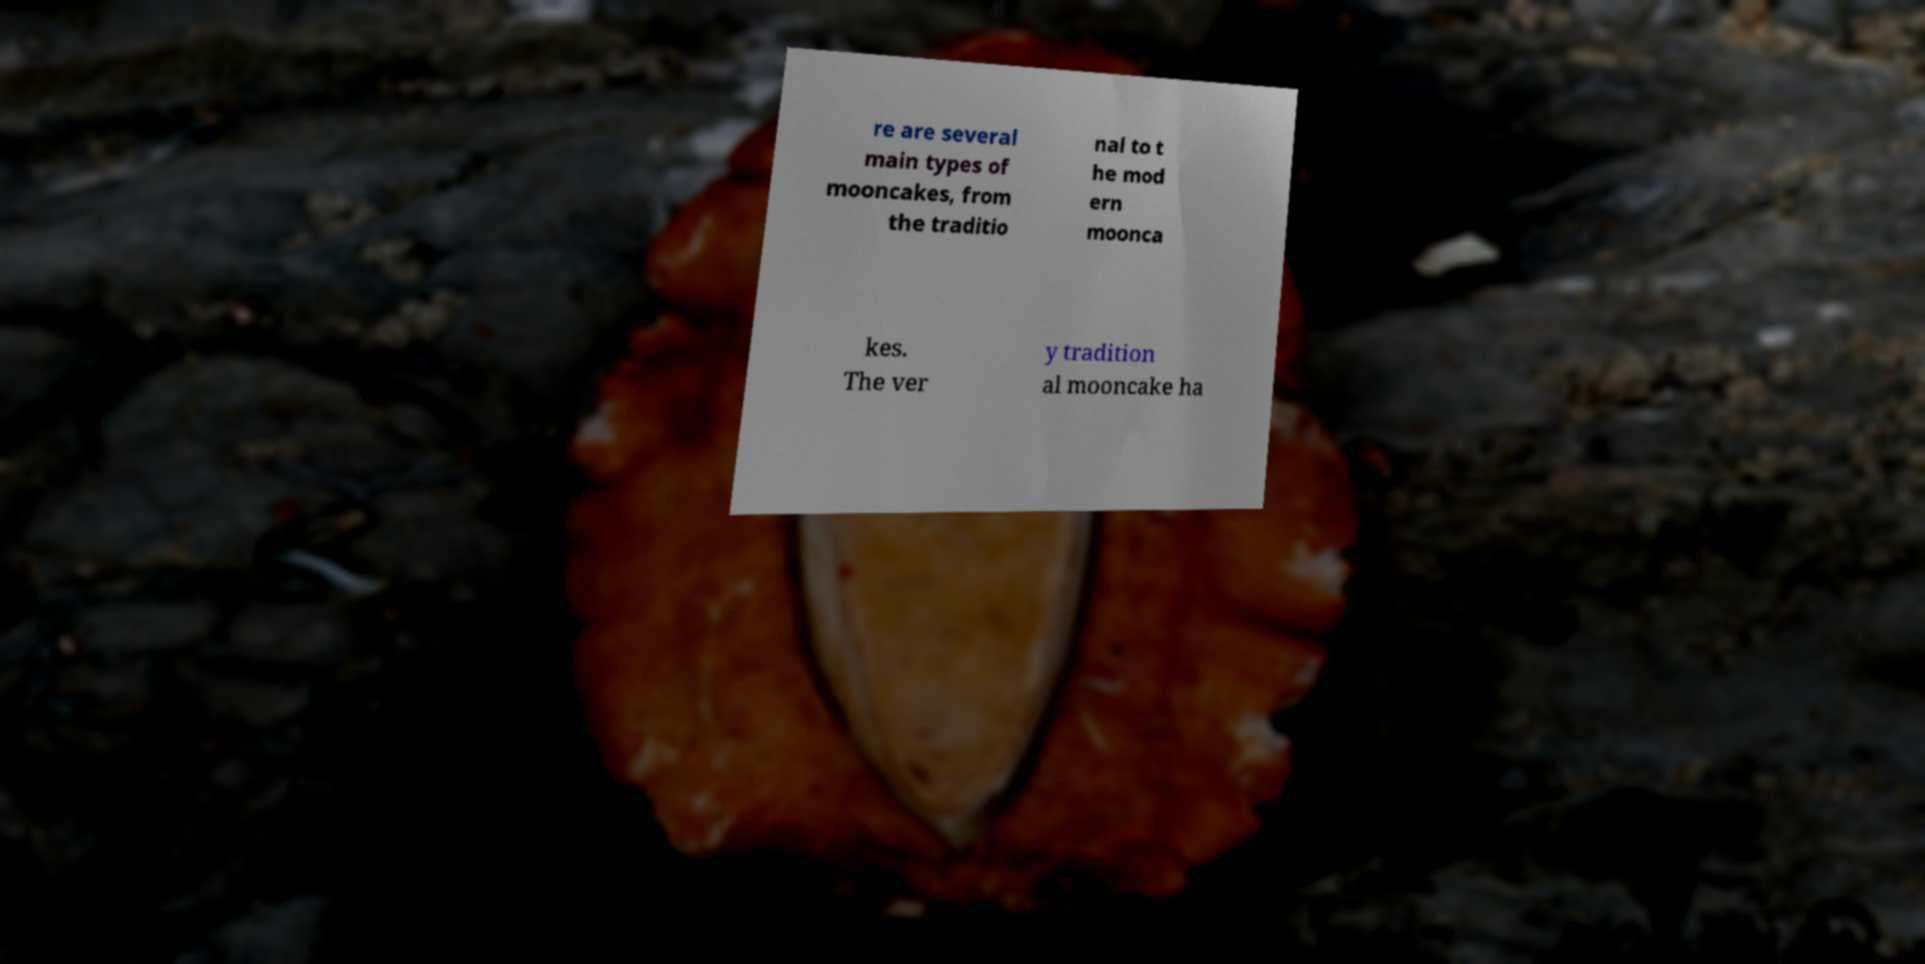Can you accurately transcribe the text from the provided image for me? re are several main types of mooncakes, from the traditio nal to t he mod ern moonca kes. The ver y tradition al mooncake ha 